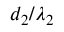<formula> <loc_0><loc_0><loc_500><loc_500>d _ { 2 } / \lambda _ { 2 }</formula> 